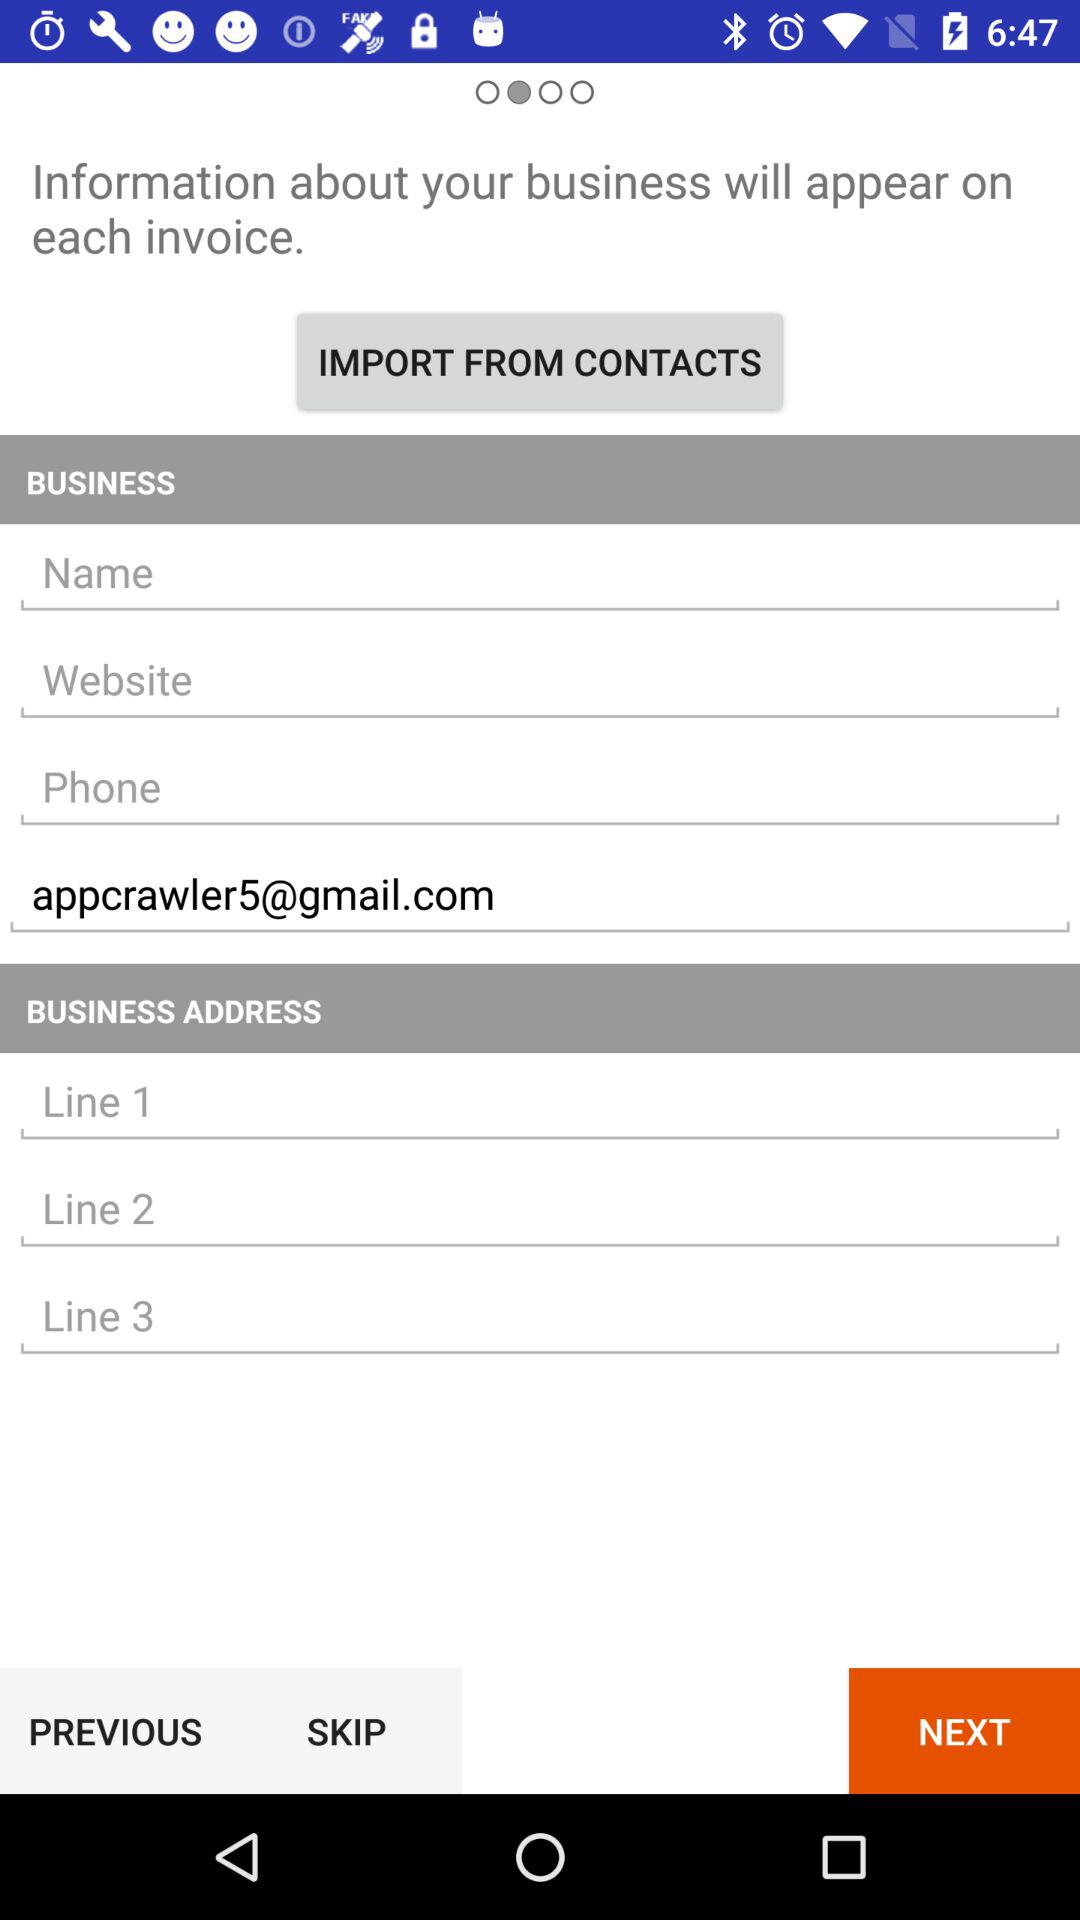What Gmail address is used? The used Gmail address is appcrawler5@gmail.com. 